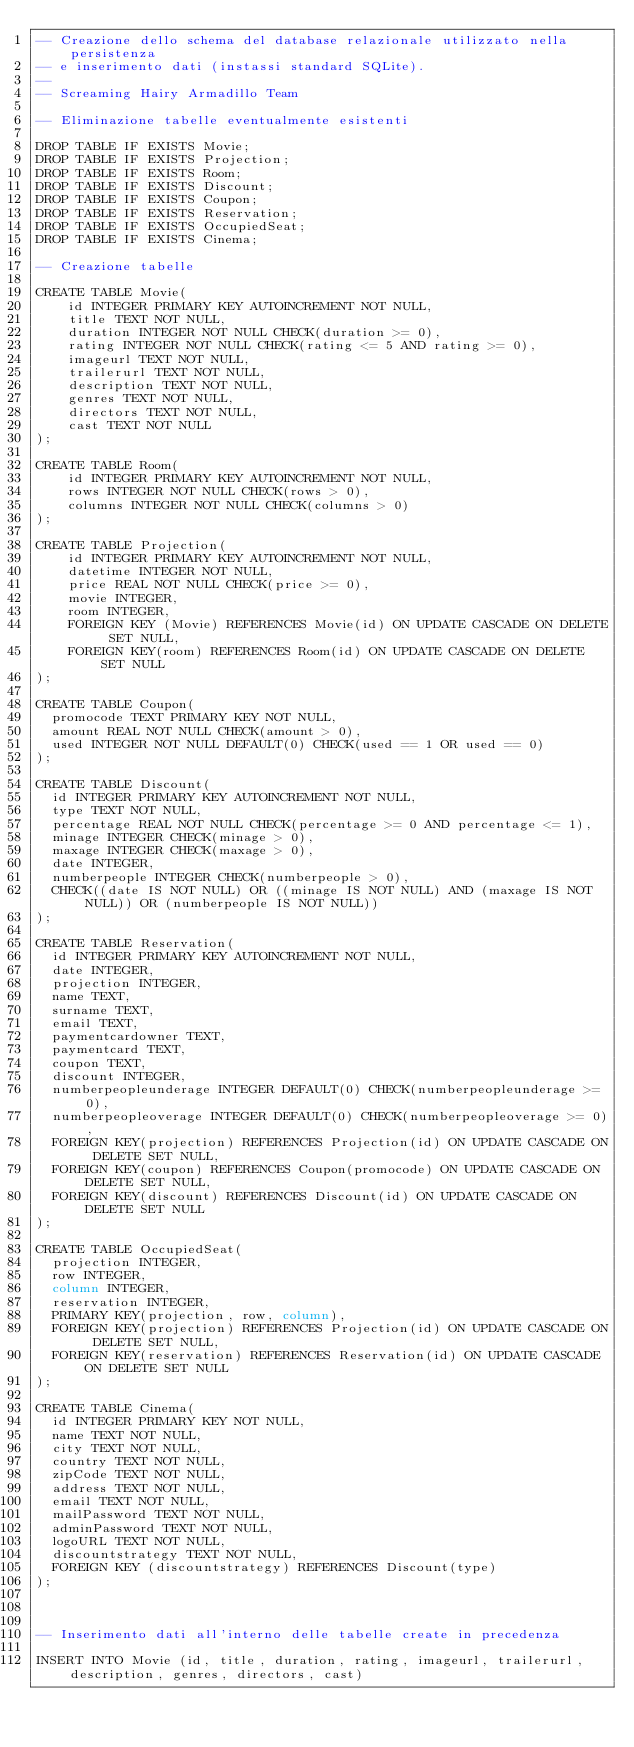<code> <loc_0><loc_0><loc_500><loc_500><_SQL_>-- Creazione dello schema del database relazionale utilizzato nella persistenza
-- e inserimento dati (instassi standard SQLite).
--
-- Screaming Hairy Armadillo Team

-- Eliminazione tabelle eventualmente esistenti

DROP TABLE IF EXISTS Movie;
DROP TABLE IF EXISTS Projection;
DROP TABLE IF EXISTS Room;
DROP TABLE IF EXISTS Discount;
DROP TABLE IF EXISTS Coupon;
DROP TABLE IF EXISTS Reservation;
DROP TABLE IF EXISTS OccupiedSeat;
DROP TABLE IF EXISTS Cinema;

-- Creazione tabelle

CREATE TABLE Movie(
    id INTEGER PRIMARY KEY AUTOINCREMENT NOT NULL,
    title TEXT NOT NULL,
    duration INTEGER NOT NULL CHECK(duration >= 0),
    rating INTEGER NOT NULL CHECK(rating <= 5 AND rating >= 0),
    imageurl TEXT NOT NULL,
    trailerurl TEXT NOT NULL,
    description TEXT NOT NULL,
    genres TEXT NOT NULL,
    directors TEXT NOT NULL,
    cast TEXT NOT NULL
);

CREATE TABLE Room(
    id INTEGER PRIMARY KEY AUTOINCREMENT NOT NULL,
    rows INTEGER NOT NULL CHECK(rows > 0),
    columns INTEGER NOT NULL CHECK(columns > 0)
);

CREATE TABLE Projection(
    id INTEGER PRIMARY KEY AUTOINCREMENT NOT NULL,
    datetime INTEGER NOT NULL,
    price REAL NOT NULL CHECK(price >= 0),
    movie INTEGER,
    room INTEGER,
    FOREIGN KEY (Movie) REFERENCES Movie(id) ON UPDATE CASCADE ON DELETE SET NULL,
    FOREIGN KEY(room) REFERENCES Room(id) ON UPDATE CASCADE ON DELETE SET NULL
);

CREATE TABLE Coupon(
	promocode TEXT PRIMARY KEY NOT NULL,
	amount REAL NOT NULL CHECK(amount > 0),
	used INTEGER NOT NULL DEFAULT(0) CHECK(used == 1 OR used == 0)
);

CREATE TABLE Discount(
	id INTEGER PRIMARY KEY AUTOINCREMENT NOT NULL,
	type TEXT NOT NULL,
	percentage REAL NOT NULL CHECK(percentage >= 0 AND percentage <= 1),
	minage INTEGER CHECK(minage > 0),
	maxage INTEGER CHECK(maxage > 0),
	date INTEGER,
	numberpeople INTEGER CHECK(numberpeople > 0),
	CHECK((date IS NOT NULL) OR ((minage IS NOT NULL) AND (maxage IS NOT NULL)) OR (numberpeople IS NOT NULL))
);

CREATE TABLE Reservation(
	id INTEGER PRIMARY KEY AUTOINCREMENT NOT NULL,
	date INTEGER,
	projection INTEGER,
	name TEXT,
	surname TEXT,
	email TEXT,
	paymentcardowner TEXT,
	paymentcard TEXT,
	coupon TEXT,
	discount INTEGER,
	numberpeopleunderage INTEGER DEFAULT(0) CHECK(numberpeopleunderage >= 0),
	numberpeopleoverage INTEGER DEFAULT(0) CHECK(numberpeopleoverage >= 0),
	FOREIGN KEY(projection) REFERENCES Projection(id) ON UPDATE CASCADE ON DELETE SET NULL,
	FOREIGN KEY(coupon) REFERENCES Coupon(promocode) ON UPDATE CASCADE ON DELETE SET NULL,
	FOREIGN KEY(discount) REFERENCES Discount(id) ON UPDATE CASCADE ON DELETE SET NULL
);

CREATE TABLE OccupiedSeat(
	projection INTEGER,
	row INTEGER,
	column INTEGER,
	reservation INTEGER,
	PRIMARY KEY(projection, row, column),
	FOREIGN KEY(projection) REFERENCES Projection(id) ON UPDATE CASCADE ON DELETE SET NULL,
	FOREIGN KEY(reservation) REFERENCES Reservation(id) ON UPDATE CASCADE ON DELETE SET NULL
);

CREATE TABLE Cinema(
	id INTEGER PRIMARY KEY NOT NULL,
	name TEXT NOT NULL,
	city TEXT NOT NULL,
	country TEXT NOT NULL,
	zipCode TEXT NOT NULL,
	address TEXT NOT NULL,
	email TEXT NOT NULL,
	mailPassword TEXT NOT NULL,
	adminPassword TEXT NOT NULL,
	logoURL TEXT NOT NULL,
	discountstrategy TEXT NOT NULL,
	FOREIGN KEY (discountstrategy) REFERENCES Discount(type)
);



-- Inserimento dati all'interno delle tabelle create in precedenza

INSERT INTO Movie (id, title, duration, rating, imageurl, trailerurl, description, genres, directors, cast)</code> 